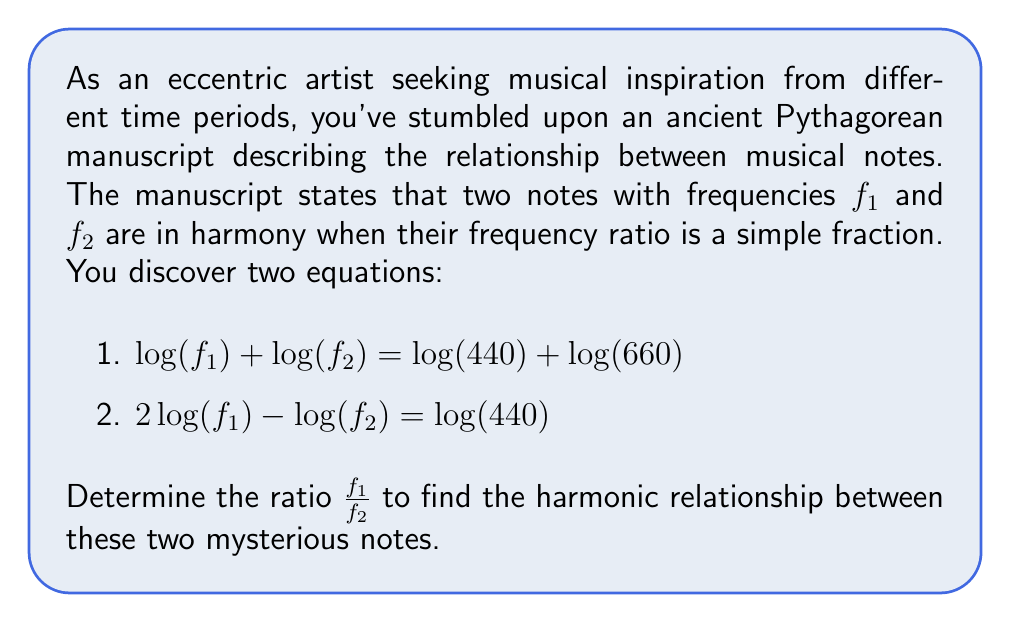Can you answer this question? Let's approach this step-by-step:

1) First, let's simplify our notation. Let $x = \log(f_1)$ and $y = \log(f_2)$. Our system of equations becomes:

   $$x + y = \log(440) + \log(660)$$
   $$2x - y = \log(440)$$

2) We can simplify the right side of the first equation:
   $$x + y = \log(440 \cdot 660) = \log(290400)$$

3) Now we have the system:
   $$x + y = \log(290400)$$
   $$2x - y = \log(440)$$

4) Add these equations to eliminate y:
   $$3x = \log(290400) + \log(440) = \log(127776000)$$

5) Solve for x:
   $$x = \frac{1}{3}\log(127776000) = \log(504)$$

6) Therefore, $f_1 = 504$ Hz

7) Substitute this back into either original equation to find $f_2$:
   $$\log(504) + \log(f_2) = \log(290400)$$
   $$\log(f_2) = \log(290400) - \log(504) = \log(576)$$

8) Therefore, $f_2 = 576$ Hz

9) The ratio $\frac{f_1}{f_2}$ is:
   $$\frac{f_1}{f_2} = \frac{504}{576} = \frac{7}{8}$$
Answer: The frequency ratio of the two notes is $\frac{7}{8}$. 